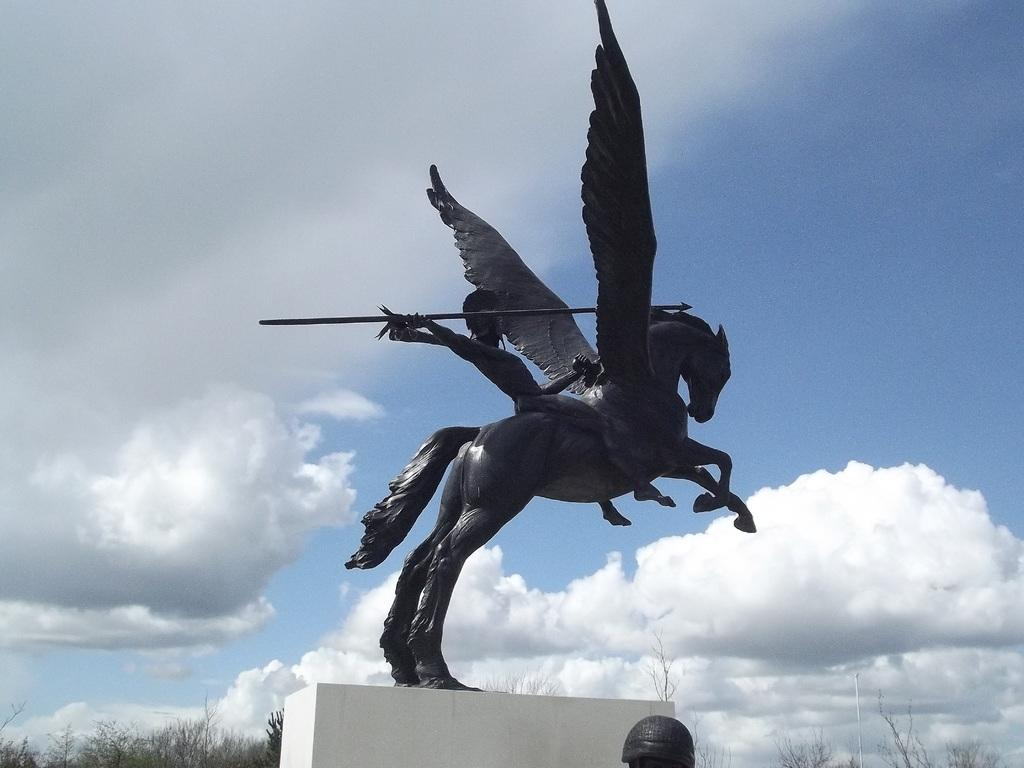What is on the wall in the image? There is a sculpture on the wall in the image. What can be seen in the sky in the image? Clouds are visible in the sky in the image. What type of vegetation is present in the image? Trees are present in the image. What brand of toothpaste is being advertised by the sculpture on the wall? There is no toothpaste or advertisement present in the image; it features a sculpture on the wall and clouds in the sky. How does the sculpture transport people in the image? The sculpture does not transport people in the image; it is a stationary object on the wall. 